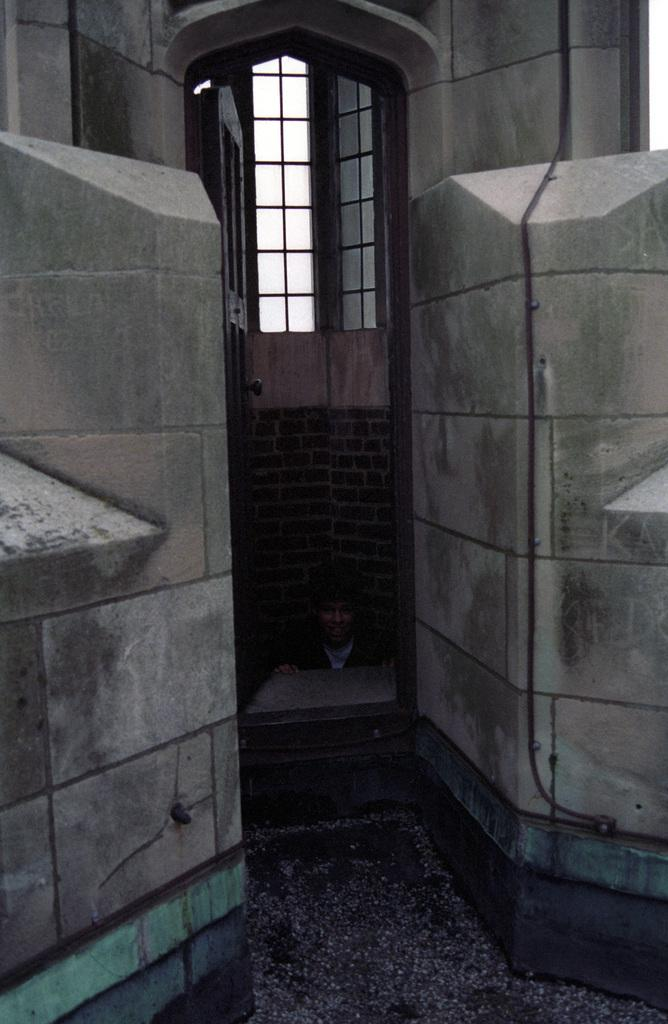What type of walls are visible in the image? There are brick walls in the image. What color are the brick walls? The brick walls are red in color. What is located above the brick walls? There is a window above the brick walls. What is in front of the window? There is a door in front of the window. Who is present in the image? A man is standing between the two walls. What type of alley can be seen in the image? There is no alley present in the image; it features brick walls, a window, a door, and a man standing between the walls. What kind of body is visible in the image? There is no body present in the image, only a man standing between the walls. 